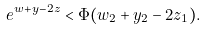Convert formula to latex. <formula><loc_0><loc_0><loc_500><loc_500>e ^ { w + y - 2 z } < \Phi ( w _ { 2 } + y _ { 2 } - 2 z _ { 1 } ) .</formula> 